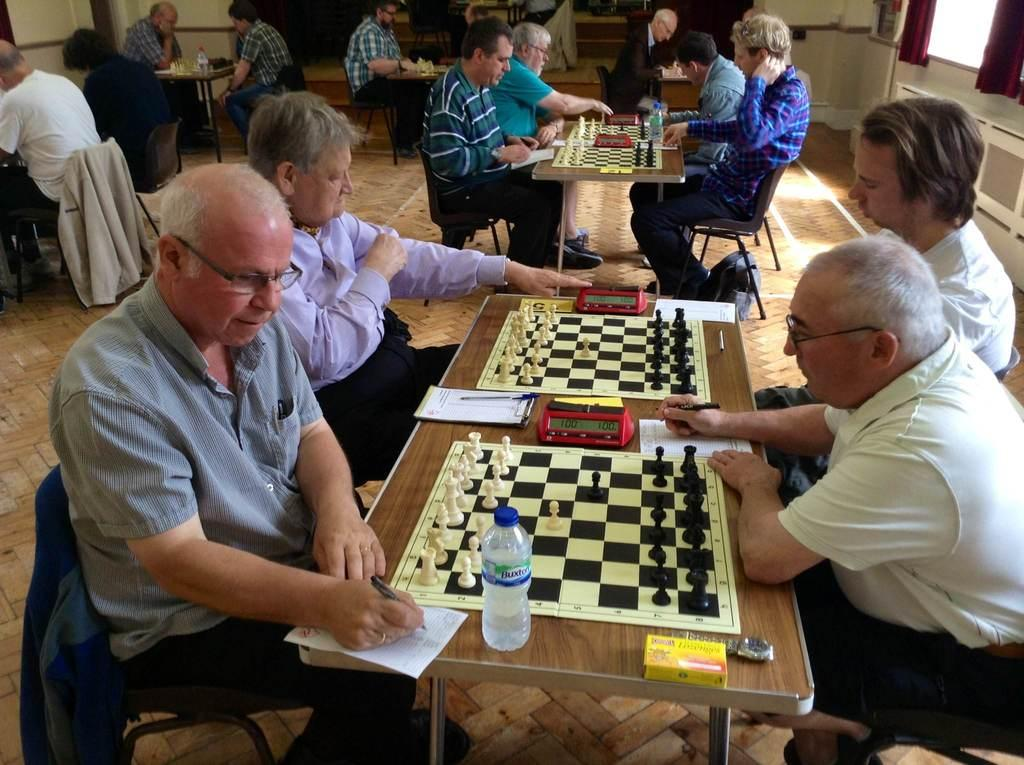How many people are in the image? There are two old men in the image. What are the old men doing in the image? The old men are playing chess. Where are the old men sitting in the image? The old men are sitting on chairs on either side of a table. What does the scene in the image suggest? The scene appears to be a chess competition. What type of birds can be seen flying in the background of the image? There are no birds visible in the image; it features two old men playing chess. 